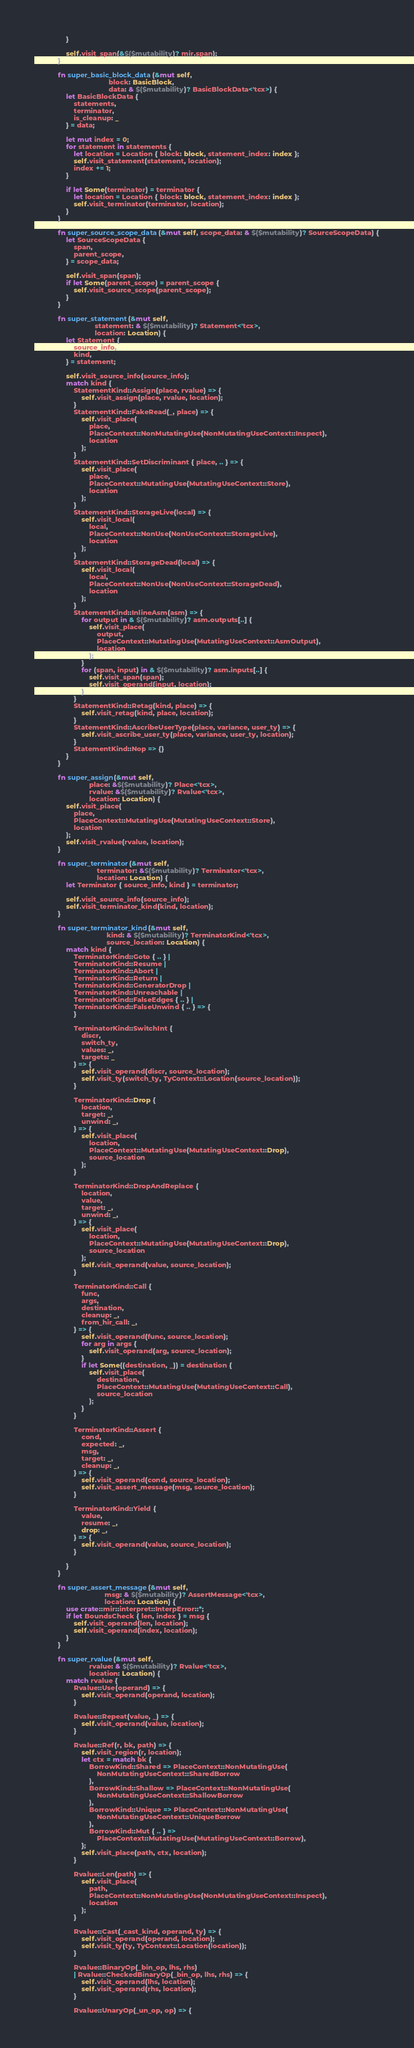<code> <loc_0><loc_0><loc_500><loc_500><_Rust_>                }

                self.visit_span(&$($mutability)? mir.span);
            }

            fn super_basic_block_data(&mut self,
                                      block: BasicBlock,
                                      data: & $($mutability)? BasicBlockData<'tcx>) {
                let BasicBlockData {
                    statements,
                    terminator,
                    is_cleanup: _
                } = data;

                let mut index = 0;
                for statement in statements {
                    let location = Location { block: block, statement_index: index };
                    self.visit_statement(statement, location);
                    index += 1;
                }

                if let Some(terminator) = terminator {
                    let location = Location { block: block, statement_index: index };
                    self.visit_terminator(terminator, location);
                }
            }

            fn super_source_scope_data(&mut self, scope_data: & $($mutability)? SourceScopeData) {
                let SourceScopeData {
                    span,
                    parent_scope,
                } = scope_data;

                self.visit_span(span);
                if let Some(parent_scope) = parent_scope {
                    self.visit_source_scope(parent_scope);
                }
            }

            fn super_statement(&mut self,
                               statement: & $($mutability)? Statement<'tcx>,
                               location: Location) {
                let Statement {
                    source_info,
                    kind,
                } = statement;

                self.visit_source_info(source_info);
                match kind {
                    StatementKind::Assign(place, rvalue) => {
                        self.visit_assign(place, rvalue, location);
                    }
                    StatementKind::FakeRead(_, place) => {
                        self.visit_place(
                            place,
                            PlaceContext::NonMutatingUse(NonMutatingUseContext::Inspect),
                            location
                        );
                    }
                    StatementKind::SetDiscriminant { place, .. } => {
                        self.visit_place(
                            place,
                            PlaceContext::MutatingUse(MutatingUseContext::Store),
                            location
                        );
                    }
                    StatementKind::StorageLive(local) => {
                        self.visit_local(
                            local,
                            PlaceContext::NonUse(NonUseContext::StorageLive),
                            location
                        );
                    }
                    StatementKind::StorageDead(local) => {
                        self.visit_local(
                            local,
                            PlaceContext::NonUse(NonUseContext::StorageDead),
                            location
                        );
                    }
                    StatementKind::InlineAsm(asm) => {
                        for output in & $($mutability)? asm.outputs[..] {
                            self.visit_place(
                                output,
                                PlaceContext::MutatingUse(MutatingUseContext::AsmOutput),
                                location
                            );
                        }
                        for (span, input) in & $($mutability)? asm.inputs[..] {
                            self.visit_span(span);
                            self.visit_operand(input, location);
                        }
                    }
                    StatementKind::Retag(kind, place) => {
                        self.visit_retag(kind, place, location);
                    }
                    StatementKind::AscribeUserType(place, variance, user_ty) => {
                        self.visit_ascribe_user_ty(place, variance, user_ty, location);
                    }
                    StatementKind::Nop => {}
                }
            }

            fn super_assign(&mut self,
                            place: &$($mutability)? Place<'tcx>,
                            rvalue: &$($mutability)? Rvalue<'tcx>,
                            location: Location) {
                self.visit_place(
                    place,
                    PlaceContext::MutatingUse(MutatingUseContext::Store),
                    location
                );
                self.visit_rvalue(rvalue, location);
            }

            fn super_terminator(&mut self,
                                terminator: &$($mutability)? Terminator<'tcx>,
                                location: Location) {
                let Terminator { source_info, kind } = terminator;

                self.visit_source_info(source_info);
                self.visit_terminator_kind(kind, location);
            }

            fn super_terminator_kind(&mut self,
                                     kind: & $($mutability)? TerminatorKind<'tcx>,
                                     source_location: Location) {
                match kind {
                    TerminatorKind::Goto { .. } |
                    TerminatorKind::Resume |
                    TerminatorKind::Abort |
                    TerminatorKind::Return |
                    TerminatorKind::GeneratorDrop |
                    TerminatorKind::Unreachable |
                    TerminatorKind::FalseEdges { .. } |
                    TerminatorKind::FalseUnwind { .. } => {
                    }

                    TerminatorKind::SwitchInt {
                        discr,
                        switch_ty,
                        values: _,
                        targets: _
                    } => {
                        self.visit_operand(discr, source_location);
                        self.visit_ty(switch_ty, TyContext::Location(source_location));
                    }

                    TerminatorKind::Drop {
                        location,
                        target: _,
                        unwind: _,
                    } => {
                        self.visit_place(
                            location,
                            PlaceContext::MutatingUse(MutatingUseContext::Drop),
                            source_location
                        );
                    }

                    TerminatorKind::DropAndReplace {
                        location,
                        value,
                        target: _,
                        unwind: _,
                    } => {
                        self.visit_place(
                            location,
                            PlaceContext::MutatingUse(MutatingUseContext::Drop),
                            source_location
                        );
                        self.visit_operand(value, source_location);
                    }

                    TerminatorKind::Call {
                        func,
                        args,
                        destination,
                        cleanup: _,
                        from_hir_call: _,
                    } => {
                        self.visit_operand(func, source_location);
                        for arg in args {
                            self.visit_operand(arg, source_location);
                        }
                        if let Some((destination, _)) = destination {
                            self.visit_place(
                                destination,
                                PlaceContext::MutatingUse(MutatingUseContext::Call),
                                source_location
                            );
                        }
                    }

                    TerminatorKind::Assert {
                        cond,
                        expected: _,
                        msg,
                        target: _,
                        cleanup: _,
                    } => {
                        self.visit_operand(cond, source_location);
                        self.visit_assert_message(msg, source_location);
                    }

                    TerminatorKind::Yield {
                        value,
                        resume: _,
                        drop: _,
                    } => {
                        self.visit_operand(value, source_location);
                    }

                }
            }

            fn super_assert_message(&mut self,
                                    msg: & $($mutability)? AssertMessage<'tcx>,
                                    location: Location) {
                use crate::mir::interpret::InterpError::*;
                if let BoundsCheck { len, index } = msg {
                    self.visit_operand(len, location);
                    self.visit_operand(index, location);
                }
            }

            fn super_rvalue(&mut self,
                            rvalue: & $($mutability)? Rvalue<'tcx>,
                            location: Location) {
                match rvalue {
                    Rvalue::Use(operand) => {
                        self.visit_operand(operand, location);
                    }

                    Rvalue::Repeat(value, _) => {
                        self.visit_operand(value, location);
                    }

                    Rvalue::Ref(r, bk, path) => {
                        self.visit_region(r, location);
                        let ctx = match bk {
                            BorrowKind::Shared => PlaceContext::NonMutatingUse(
                                NonMutatingUseContext::SharedBorrow
                            ),
                            BorrowKind::Shallow => PlaceContext::NonMutatingUse(
                                NonMutatingUseContext::ShallowBorrow
                            ),
                            BorrowKind::Unique => PlaceContext::NonMutatingUse(
                                NonMutatingUseContext::UniqueBorrow
                            ),
                            BorrowKind::Mut { .. } =>
                                PlaceContext::MutatingUse(MutatingUseContext::Borrow),
                        };
                        self.visit_place(path, ctx, location);
                    }

                    Rvalue::Len(path) => {
                        self.visit_place(
                            path,
                            PlaceContext::NonMutatingUse(NonMutatingUseContext::Inspect),
                            location
                        );
                    }

                    Rvalue::Cast(_cast_kind, operand, ty) => {
                        self.visit_operand(operand, location);
                        self.visit_ty(ty, TyContext::Location(location));
                    }

                    Rvalue::BinaryOp(_bin_op, lhs, rhs)
                    | Rvalue::CheckedBinaryOp(_bin_op, lhs, rhs) => {
                        self.visit_operand(lhs, location);
                        self.visit_operand(rhs, location);
                    }

                    Rvalue::UnaryOp(_un_op, op) => {</code> 